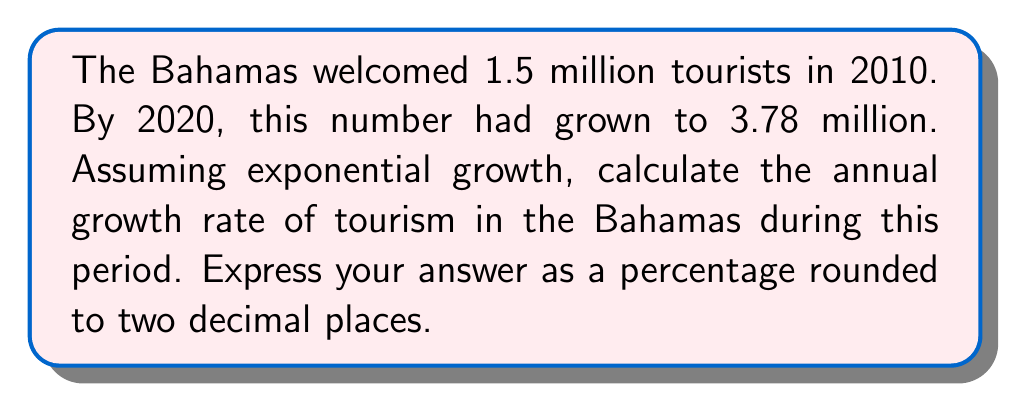Help me with this question. Let's approach this step-by-step using the exponential growth formula:

1) The exponential growth formula is:
   $A = P(1 + r)^t$
   Where:
   $A$ is the final amount
   $P$ is the initial amount
   $r$ is the annual growth rate
   $t$ is the time in years

2) We know:
   $P = 1.5$ million (initial tourists in 2010)
   $A = 3.78$ million (final tourists in 2020)
   $t = 10$ years

3) Let's plug these into our formula:
   $3.78 = 1.5(1 + r)^{10}$

4) Divide both sides by 1.5:
   $2.52 = (1 + r)^{10}$

5) Take the 10th root of both sides:
   $\sqrt[10]{2.52} = 1 + r$

6) Subtract 1 from both sides:
   $\sqrt[10]{2.52} - 1 = r$

7) Calculate:
   $r = 1.0968 - 1 = 0.0968$

8) Convert to a percentage:
   $0.0968 \times 100 = 9.68\%$
Answer: $9.68\%$ 